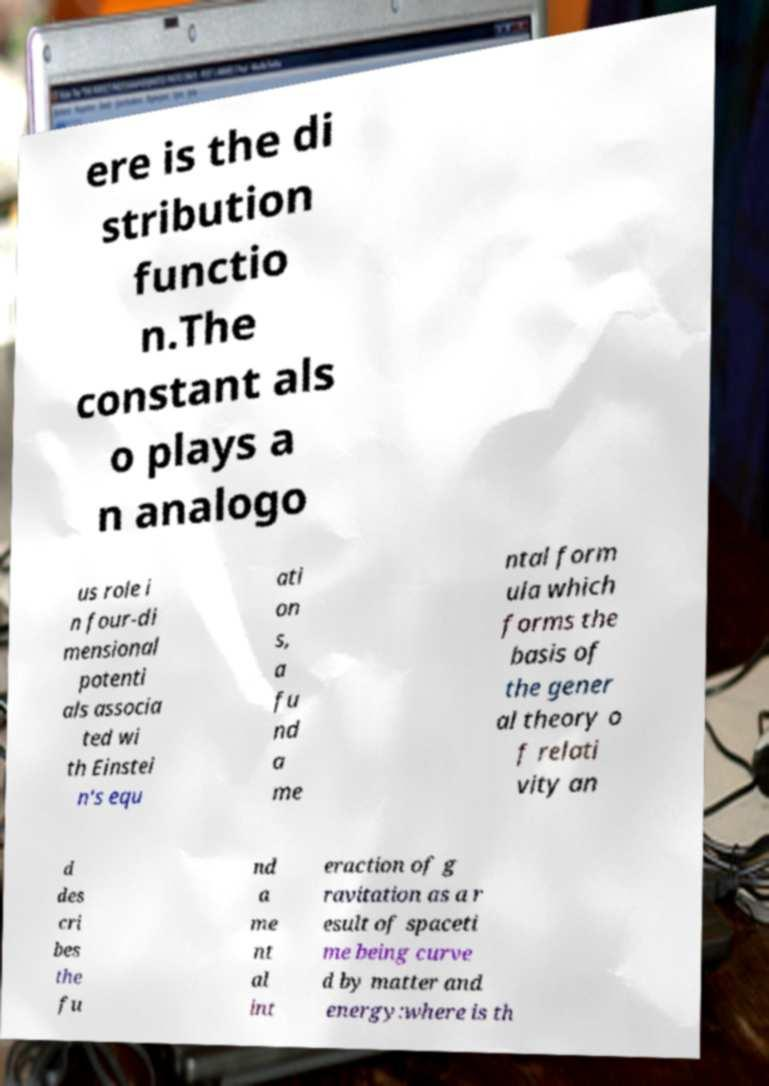Can you accurately transcribe the text from the provided image for me? ere is the di stribution functio n.The constant als o plays a n analogo us role i n four-di mensional potenti als associa ted wi th Einstei n's equ ati on s, a fu nd a me ntal form ula which forms the basis of the gener al theory o f relati vity an d des cri bes the fu nd a me nt al int eraction of g ravitation as a r esult of spaceti me being curve d by matter and energy:where is th 